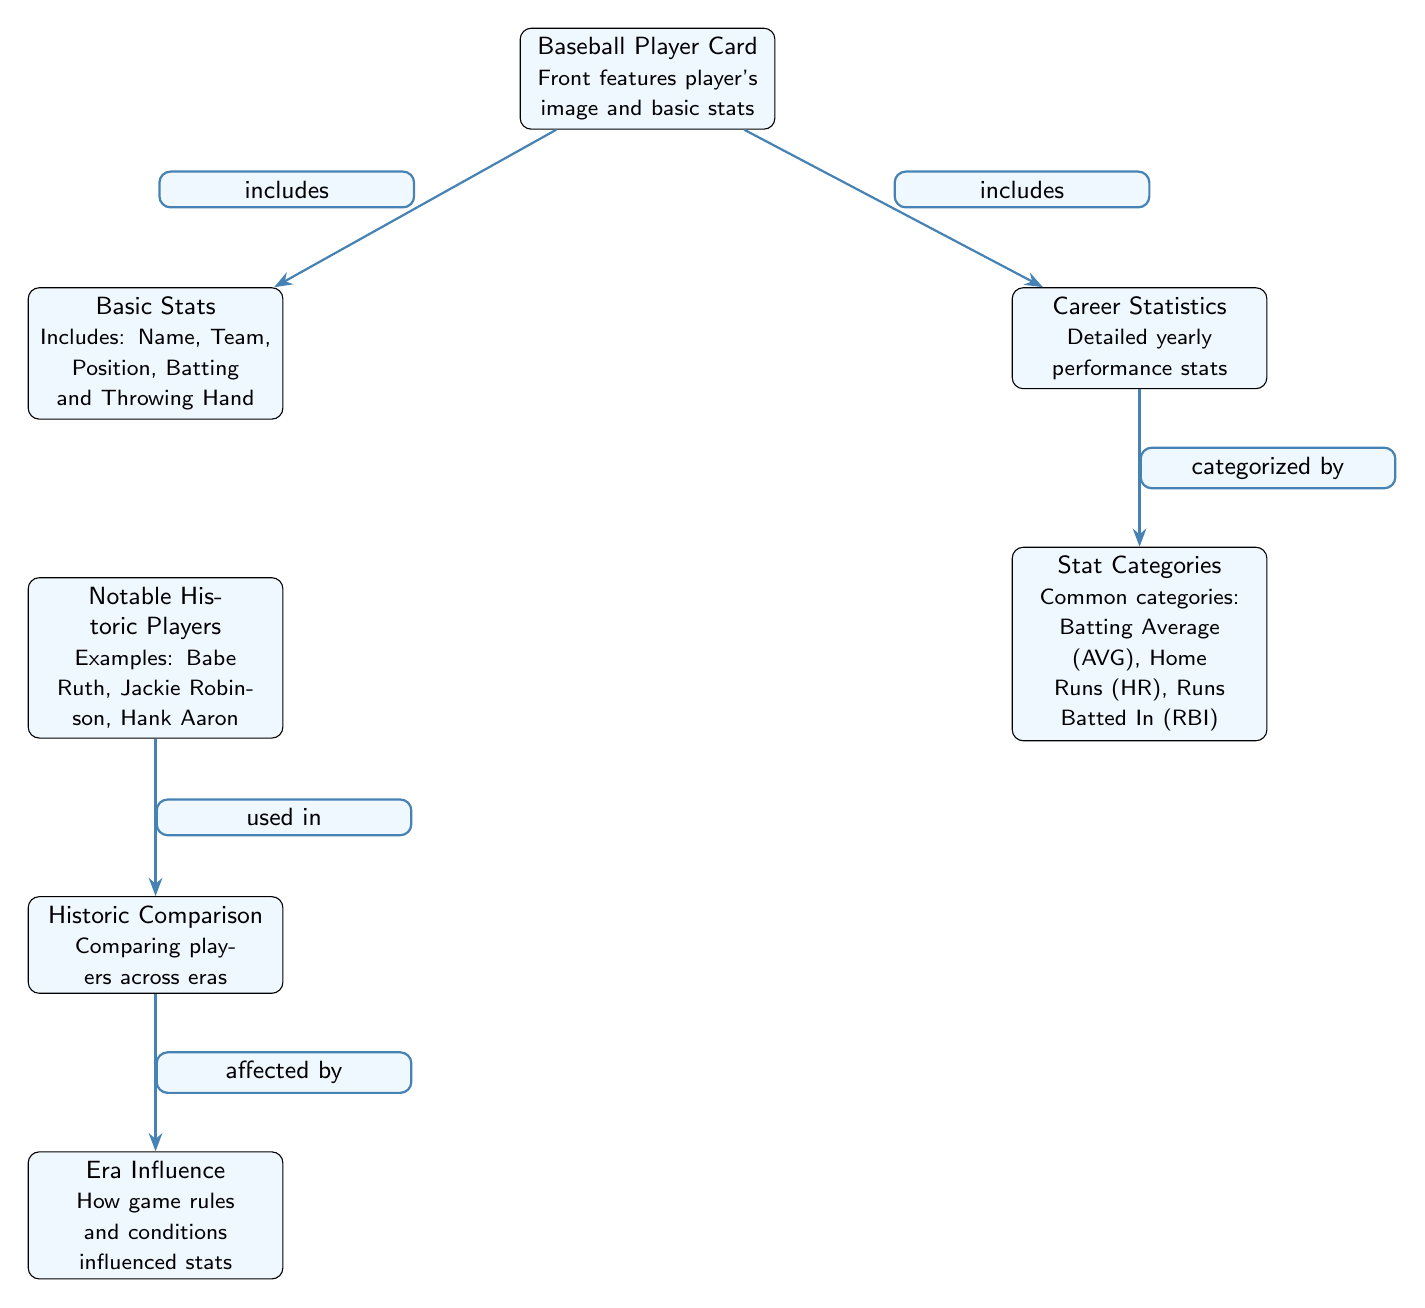What node describes the front of a baseball player card? The node labeled "Baseball Player Card" specifies its front features and statistics. Therefore, it is the node providing the description about the front of the card.
Answer: Baseball Player Card How many stat categories are listed in the diagram? The node "Stat Categories" implies that there is a count of categories that can be extracted, but there are no specific numbers mentioned in the node itself. Thus, the answer is general as the detailed count isn't provided.
Answer: Common categories What influences the historic comparison of players according to the diagram? The node "Era Influence" suggests that the conditions and rules of the game affect how player statistics are compared across different eras. Therefore, era influence is what affects historic comparisons.
Answer: Era Influence Which node is categorized under career statistics? The node "Stat Categories" is connected by the edge labeled "categorized by," indicating it is a categorization derived from "Career Statistics." Thus, the answer must pertain to that category.
Answer: Stat Categories What notable historic players are mentioned? The node "Notable Historic Players" lists examples such as Babe Ruth, Jackie Robinson, and Hank Aaron, which were clearly indicated in the node's description. As such, notable historic players can be exemplified from this node.
Answer: Babe Ruth, Jackie Robinson, Hank Aaron How does the layout indicate the relationship between player cards and basic stats? The edge labeled "includes" connects the nodes "Baseball Player Card" and "Basic Stats," showing that the player card has basic statistics as part of its features, clarifying their relationship.
Answer: includes What does the node "Career Statistics" provide? The node directly states "Detailed yearly performance stats" which informs about the substance of what is contained within the career statistics. Hence, it conveys the main focus of the category represented.
Answer: Detailed yearly performance stats Which node would provide comparisons of players from different eras? The node "Historic Comparison" specifies that it discusses the comparisons of players across various time periods within the context of baseball, indicating its focus area.
Answer: Historic Comparison 